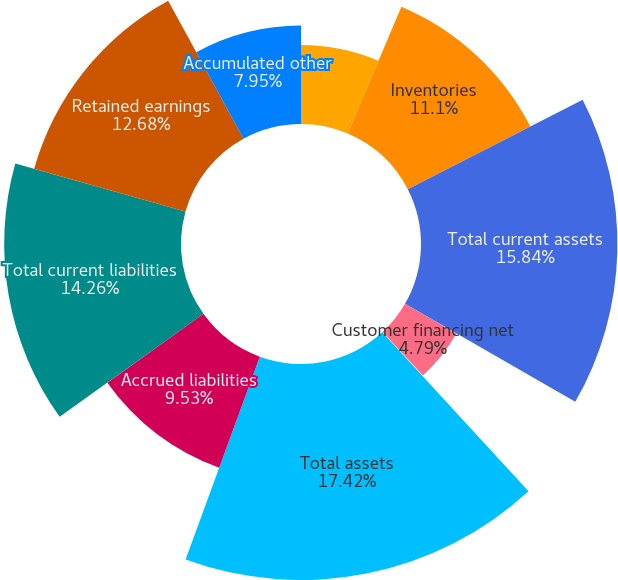Convert chart to OTSL. <chart><loc_0><loc_0><loc_500><loc_500><pie_chart><fcel>Accounts receivable net<fcel>Inventories<fcel>Total current assets<fcel>Customer financing net<fcel>Deferred income taxes<fcel>Total assets<fcel>Accrued liabilities<fcel>Total current liabilities<fcel>Retained earnings<fcel>Accumulated other<nl><fcel>6.37%<fcel>11.1%<fcel>15.84%<fcel>4.79%<fcel>0.06%<fcel>17.42%<fcel>9.53%<fcel>14.26%<fcel>12.68%<fcel>7.95%<nl></chart> 